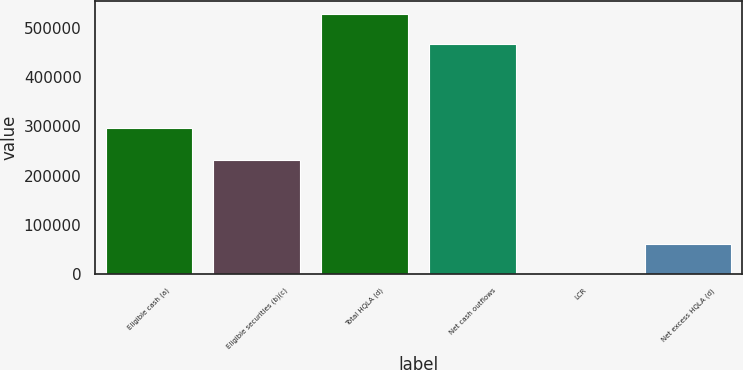<chart> <loc_0><loc_0><loc_500><loc_500><bar_chart><fcel>Eligible cash (a)<fcel>Eligible securities (b)(c)<fcel>Total HQLA (d)<fcel>Net cash outflows<fcel>LCR<fcel>Net excess HQLA (d)<nl><fcel>297069<fcel>232201<fcel>529270<fcel>467704<fcel>113<fcel>61566<nl></chart> 